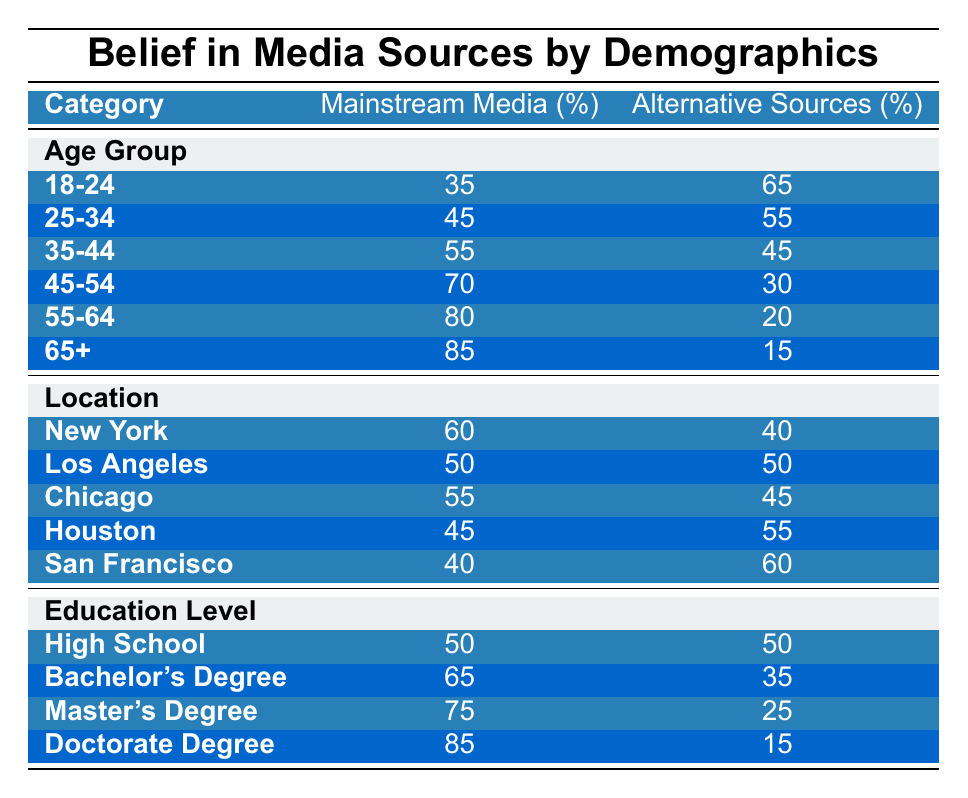What percentage of the 18-24 age group believes in mainstream media? The table indicates that 35% of the 18-24 age group believes in mainstream media, as this percentage is explicitly listed under the age group section.
Answer: 35% Which age group has the highest belief in alternative sources? By examining the table, the 18-24 age group has the highest belief in alternative sources at 65%, more than any other age group listed.
Answer: 18-24 What is the difference in belief in mainstream media between those with a Doctorate and those with a High School education? The belief in mainstream media is 85% for Doctorate holders and 50% for High School graduates. The difference is 85 - 50 = 35%.
Answer: 35% Do more people in San Francisco believe in alternative sources than in New York? In San Francisco, 60% believe in alternative sources, whereas in New York, it is 40%. Therefore, yes, more people in San Francisco believe in alternative sources.
Answer: Yes What is the average belief in mainstream media across all age groups? The average belief can be calculated by adding all the percentages for mainstream media (35 + 45 + 55 + 70 + 80 + 85 = 370) and then dividing by the number of age groups (6). Thus, the average is 370 / 6 = 61.67%.
Answer: 61.67% 